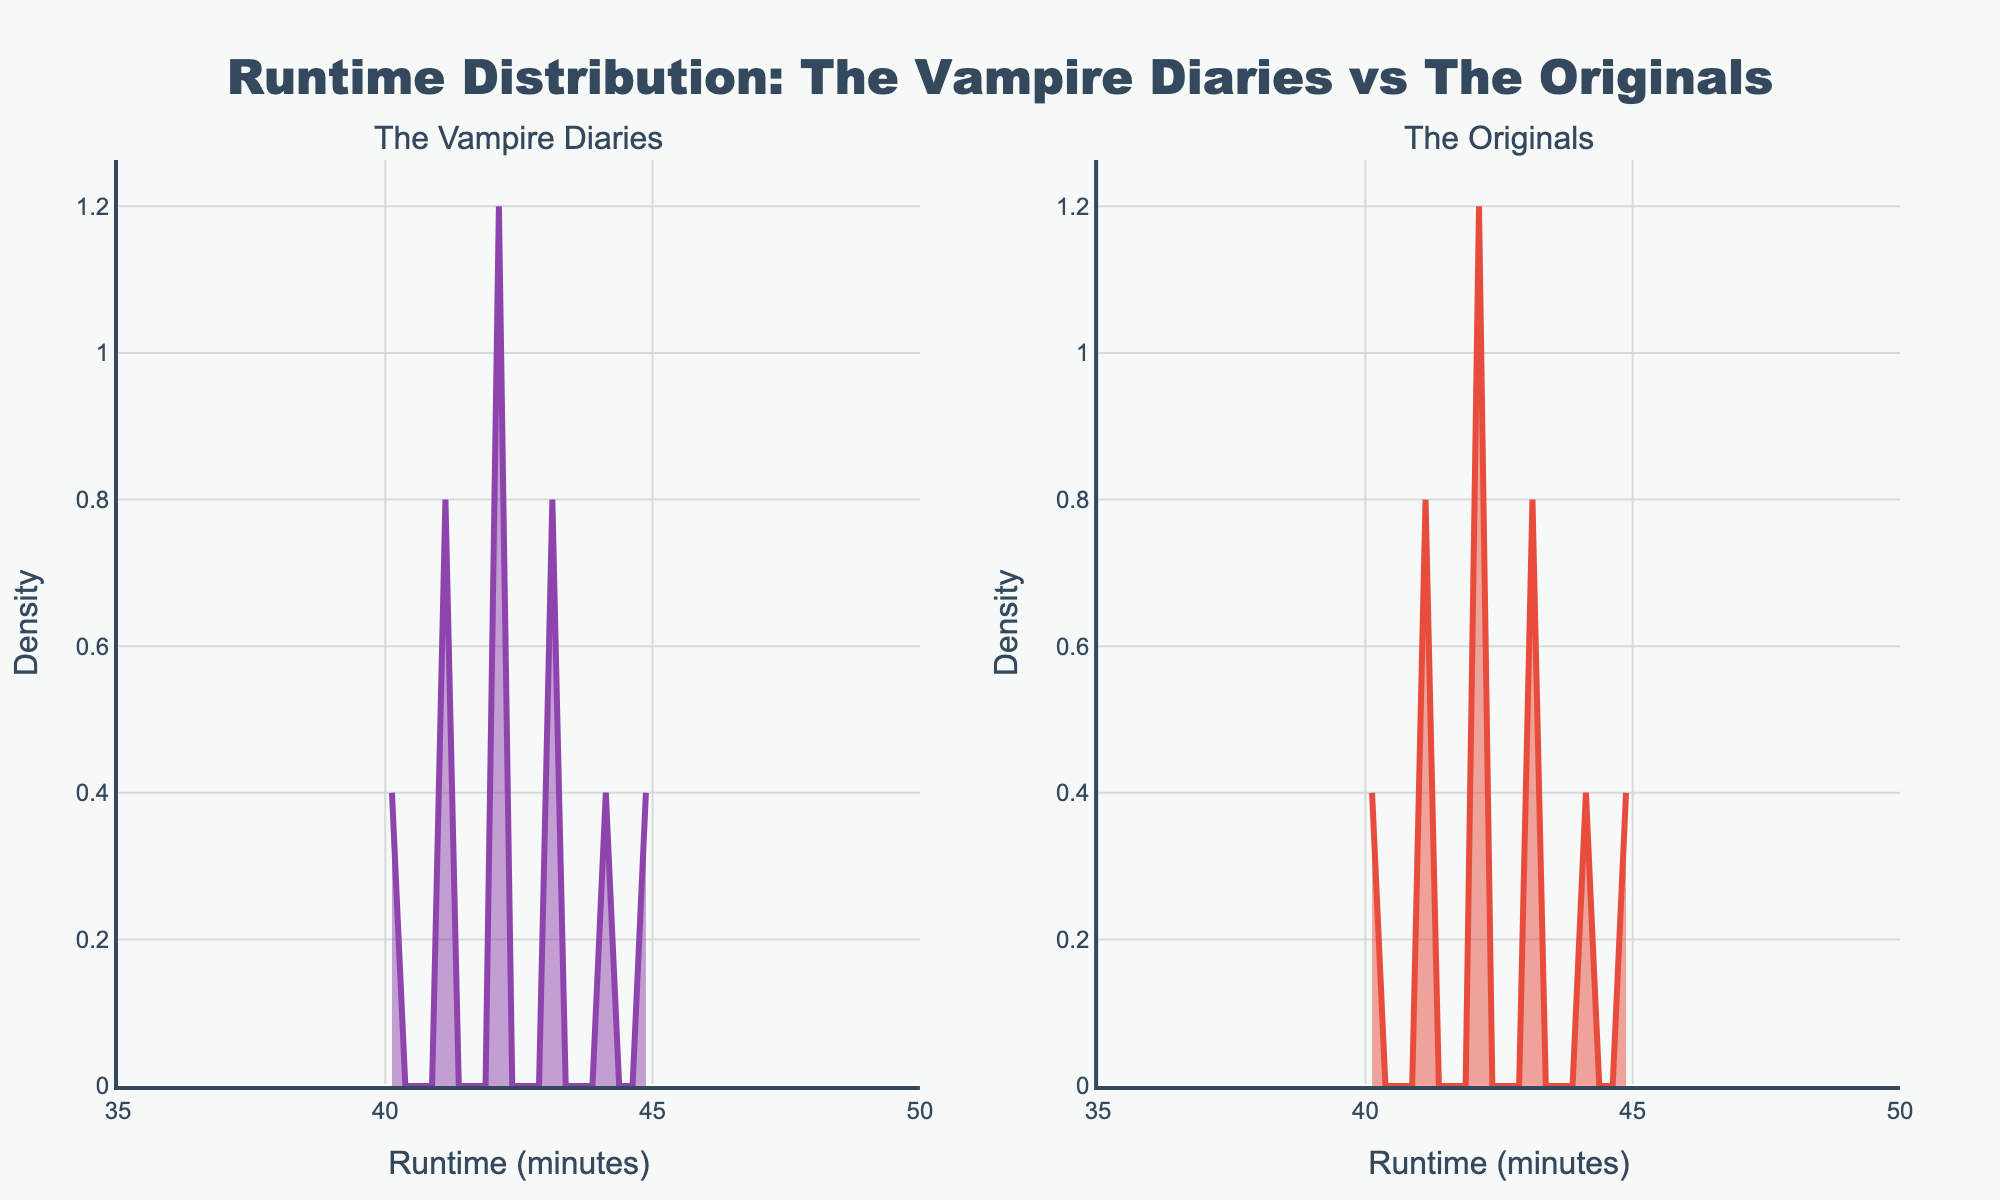What is the title of the figure? The title of the figure is located at the top and reads "Runtime Distribution: The Vampire Diaries vs The Originals".
Answer: Runtime Distribution: The Vampire Diaries vs The Originals Which subplot is dedicated to The Vampire Diaries? The Vampire Diaries' subplot is labeled as the left subplot with the title "The Vampire Diaries".
Answer: Left subplot What is the range of runtime values displayed on the x-axis? The x-axis displays values ranging from 35 to 50 minutes, as indicated by the axis labels.
Answer: 35 to 50 minutes Which series has a runtime density peak at 42 minutes? Looking at the density peaks, both The Vampire Diaries and The Originals have a peak at the 42-minute mark.
Answer: Both series Which subplot has a higher runtime density at 41 minutes? By comparing the height of the density curves at 41 minutes, we can see that both subplots have similar density values.
Answer: Both subplots What runtime value corresponds to the highest density peak in The Vampire Diaries subplot? Observing the subplot for The Vampire Diaries, the highest peak occurs at the runtime value of 42 minutes.
Answer: 42 minutes On which subplot does the KDE line color appear red? The KDE line color for The Originals is red, while The Vampire Diaries has a purple KDE line.
Answer: The Originals subplot Between 43 and 45 minutes, which series has a wider density spread? By observing the spread of the density curves, The Originals has a wider spread between 43 and 45 minutes compared to The Vampire Diaries.
Answer: The Originals What is the y-axis label? The y-axis label, which can be found next to the vertical axis, is "Density".
Answer: Density How do the maximum density values for each series compare at 40 minutes? At 40 minutes, both series have similar density values, suggesting comparable runtime distributions.
Answer: Similar density values 